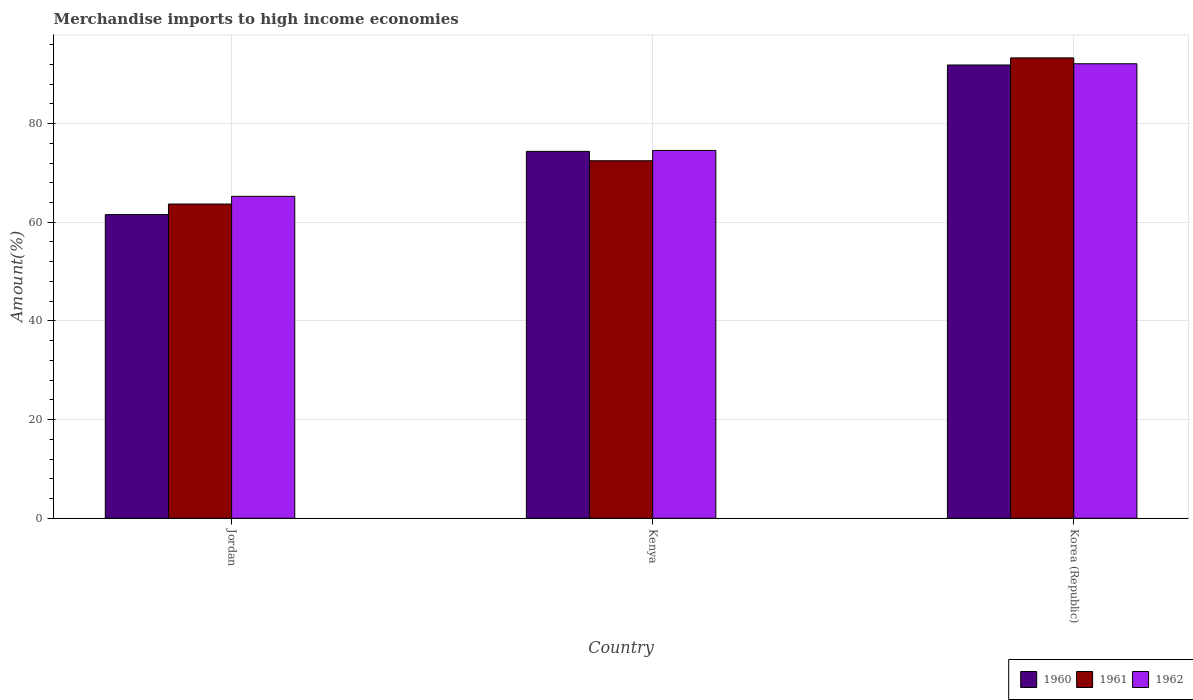How many bars are there on the 3rd tick from the right?
Keep it short and to the point. 3. What is the label of the 1st group of bars from the left?
Your answer should be very brief. Jordan. What is the percentage of amount earned from merchandise imports in 1962 in Korea (Republic)?
Your answer should be compact. 92.12. Across all countries, what is the maximum percentage of amount earned from merchandise imports in 1962?
Make the answer very short. 92.12. Across all countries, what is the minimum percentage of amount earned from merchandise imports in 1962?
Give a very brief answer. 65.24. In which country was the percentage of amount earned from merchandise imports in 1961 maximum?
Provide a short and direct response. Korea (Republic). In which country was the percentage of amount earned from merchandise imports in 1962 minimum?
Give a very brief answer. Jordan. What is the total percentage of amount earned from merchandise imports in 1962 in the graph?
Give a very brief answer. 231.92. What is the difference between the percentage of amount earned from merchandise imports in 1962 in Jordan and that in Korea (Republic)?
Ensure brevity in your answer.  -26.88. What is the difference between the percentage of amount earned from merchandise imports in 1962 in Korea (Republic) and the percentage of amount earned from merchandise imports in 1961 in Kenya?
Offer a terse response. 19.66. What is the average percentage of amount earned from merchandise imports in 1962 per country?
Provide a short and direct response. 77.31. What is the difference between the percentage of amount earned from merchandise imports of/in 1961 and percentage of amount earned from merchandise imports of/in 1960 in Jordan?
Offer a terse response. 2.14. In how many countries, is the percentage of amount earned from merchandise imports in 1961 greater than 32 %?
Give a very brief answer. 3. What is the ratio of the percentage of amount earned from merchandise imports in 1960 in Jordan to that in Kenya?
Your answer should be very brief. 0.83. What is the difference between the highest and the second highest percentage of amount earned from merchandise imports in 1962?
Your answer should be very brief. -9.31. What is the difference between the highest and the lowest percentage of amount earned from merchandise imports in 1960?
Keep it short and to the point. 30.32. Is the sum of the percentage of amount earned from merchandise imports in 1961 in Jordan and Kenya greater than the maximum percentage of amount earned from merchandise imports in 1960 across all countries?
Keep it short and to the point. Yes. How many countries are there in the graph?
Your answer should be compact. 3. Does the graph contain any zero values?
Offer a very short reply. No. Does the graph contain grids?
Your answer should be very brief. Yes. Where does the legend appear in the graph?
Provide a succinct answer. Bottom right. How many legend labels are there?
Your response must be concise. 3. What is the title of the graph?
Provide a short and direct response. Merchandise imports to high income economies. Does "2004" appear as one of the legend labels in the graph?
Provide a short and direct response. No. What is the label or title of the X-axis?
Offer a terse response. Country. What is the label or title of the Y-axis?
Ensure brevity in your answer.  Amount(%). What is the Amount(%) of 1960 in Jordan?
Ensure brevity in your answer.  61.55. What is the Amount(%) of 1961 in Jordan?
Offer a very short reply. 63.69. What is the Amount(%) of 1962 in Jordan?
Keep it short and to the point. 65.24. What is the Amount(%) in 1960 in Kenya?
Keep it short and to the point. 74.36. What is the Amount(%) of 1961 in Kenya?
Your answer should be compact. 72.46. What is the Amount(%) of 1962 in Kenya?
Keep it short and to the point. 74.55. What is the Amount(%) in 1960 in Korea (Republic)?
Keep it short and to the point. 91.87. What is the Amount(%) in 1961 in Korea (Republic)?
Give a very brief answer. 93.31. What is the Amount(%) of 1962 in Korea (Republic)?
Give a very brief answer. 92.12. Across all countries, what is the maximum Amount(%) of 1960?
Provide a succinct answer. 91.87. Across all countries, what is the maximum Amount(%) of 1961?
Provide a short and direct response. 93.31. Across all countries, what is the maximum Amount(%) of 1962?
Your answer should be very brief. 92.12. Across all countries, what is the minimum Amount(%) of 1960?
Keep it short and to the point. 61.55. Across all countries, what is the minimum Amount(%) in 1961?
Offer a very short reply. 63.69. Across all countries, what is the minimum Amount(%) in 1962?
Offer a very short reply. 65.24. What is the total Amount(%) in 1960 in the graph?
Your answer should be compact. 227.78. What is the total Amount(%) in 1961 in the graph?
Your answer should be compact. 229.46. What is the total Amount(%) in 1962 in the graph?
Provide a short and direct response. 231.92. What is the difference between the Amount(%) of 1960 in Jordan and that in Kenya?
Ensure brevity in your answer.  -12.81. What is the difference between the Amount(%) of 1961 in Jordan and that in Kenya?
Provide a short and direct response. -8.77. What is the difference between the Amount(%) in 1962 in Jordan and that in Kenya?
Offer a terse response. -9.31. What is the difference between the Amount(%) in 1960 in Jordan and that in Korea (Republic)?
Your answer should be compact. -30.32. What is the difference between the Amount(%) in 1961 in Jordan and that in Korea (Republic)?
Ensure brevity in your answer.  -29.62. What is the difference between the Amount(%) in 1962 in Jordan and that in Korea (Republic)?
Give a very brief answer. -26.88. What is the difference between the Amount(%) in 1960 in Kenya and that in Korea (Republic)?
Offer a terse response. -17.51. What is the difference between the Amount(%) of 1961 in Kenya and that in Korea (Republic)?
Keep it short and to the point. -20.85. What is the difference between the Amount(%) in 1962 in Kenya and that in Korea (Republic)?
Provide a short and direct response. -17.57. What is the difference between the Amount(%) of 1960 in Jordan and the Amount(%) of 1961 in Kenya?
Keep it short and to the point. -10.91. What is the difference between the Amount(%) of 1960 in Jordan and the Amount(%) of 1962 in Kenya?
Make the answer very short. -13. What is the difference between the Amount(%) in 1961 in Jordan and the Amount(%) in 1962 in Kenya?
Provide a succinct answer. -10.86. What is the difference between the Amount(%) of 1960 in Jordan and the Amount(%) of 1961 in Korea (Republic)?
Keep it short and to the point. -31.76. What is the difference between the Amount(%) in 1960 in Jordan and the Amount(%) in 1962 in Korea (Republic)?
Provide a succinct answer. -30.57. What is the difference between the Amount(%) of 1961 in Jordan and the Amount(%) of 1962 in Korea (Republic)?
Keep it short and to the point. -28.43. What is the difference between the Amount(%) of 1960 in Kenya and the Amount(%) of 1961 in Korea (Republic)?
Provide a succinct answer. -18.95. What is the difference between the Amount(%) of 1960 in Kenya and the Amount(%) of 1962 in Korea (Republic)?
Provide a succinct answer. -17.76. What is the difference between the Amount(%) of 1961 in Kenya and the Amount(%) of 1962 in Korea (Republic)?
Your answer should be compact. -19.66. What is the average Amount(%) in 1960 per country?
Offer a terse response. 75.93. What is the average Amount(%) in 1961 per country?
Offer a very short reply. 76.49. What is the average Amount(%) in 1962 per country?
Give a very brief answer. 77.31. What is the difference between the Amount(%) in 1960 and Amount(%) in 1961 in Jordan?
Ensure brevity in your answer.  -2.14. What is the difference between the Amount(%) of 1960 and Amount(%) of 1962 in Jordan?
Provide a succinct answer. -3.69. What is the difference between the Amount(%) of 1961 and Amount(%) of 1962 in Jordan?
Offer a terse response. -1.55. What is the difference between the Amount(%) of 1960 and Amount(%) of 1961 in Kenya?
Provide a short and direct response. 1.9. What is the difference between the Amount(%) in 1960 and Amount(%) in 1962 in Kenya?
Your response must be concise. -0.2. What is the difference between the Amount(%) of 1961 and Amount(%) of 1962 in Kenya?
Make the answer very short. -2.09. What is the difference between the Amount(%) of 1960 and Amount(%) of 1961 in Korea (Republic)?
Provide a succinct answer. -1.44. What is the difference between the Amount(%) in 1960 and Amount(%) in 1962 in Korea (Republic)?
Your answer should be very brief. -0.25. What is the difference between the Amount(%) in 1961 and Amount(%) in 1962 in Korea (Republic)?
Ensure brevity in your answer.  1.19. What is the ratio of the Amount(%) of 1960 in Jordan to that in Kenya?
Offer a very short reply. 0.83. What is the ratio of the Amount(%) of 1961 in Jordan to that in Kenya?
Your response must be concise. 0.88. What is the ratio of the Amount(%) in 1962 in Jordan to that in Kenya?
Offer a terse response. 0.88. What is the ratio of the Amount(%) in 1960 in Jordan to that in Korea (Republic)?
Your response must be concise. 0.67. What is the ratio of the Amount(%) of 1961 in Jordan to that in Korea (Republic)?
Give a very brief answer. 0.68. What is the ratio of the Amount(%) of 1962 in Jordan to that in Korea (Republic)?
Make the answer very short. 0.71. What is the ratio of the Amount(%) of 1960 in Kenya to that in Korea (Republic)?
Provide a short and direct response. 0.81. What is the ratio of the Amount(%) in 1961 in Kenya to that in Korea (Republic)?
Your response must be concise. 0.78. What is the ratio of the Amount(%) of 1962 in Kenya to that in Korea (Republic)?
Your answer should be very brief. 0.81. What is the difference between the highest and the second highest Amount(%) in 1960?
Make the answer very short. 17.51. What is the difference between the highest and the second highest Amount(%) in 1961?
Your answer should be very brief. 20.85. What is the difference between the highest and the second highest Amount(%) in 1962?
Offer a terse response. 17.57. What is the difference between the highest and the lowest Amount(%) of 1960?
Your response must be concise. 30.32. What is the difference between the highest and the lowest Amount(%) in 1961?
Offer a terse response. 29.62. What is the difference between the highest and the lowest Amount(%) in 1962?
Provide a short and direct response. 26.88. 